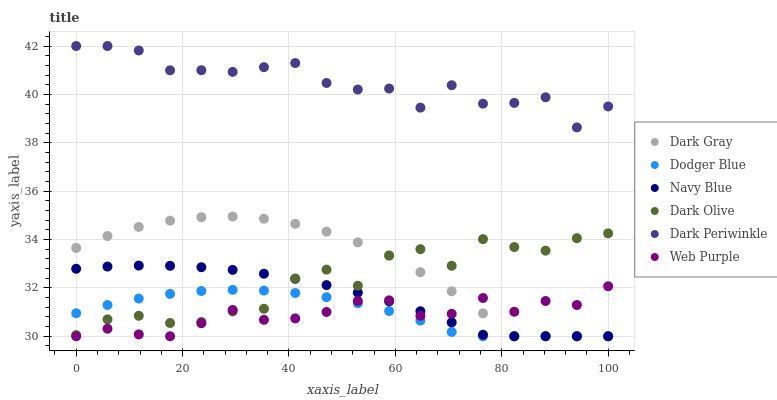Does Web Purple have the minimum area under the curve?
Answer yes or no. Yes. Does Dark Periwinkle have the maximum area under the curve?
Answer yes or no. Yes. Does Dark Olive have the minimum area under the curve?
Answer yes or no. No. Does Dark Olive have the maximum area under the curve?
Answer yes or no. No. Is Navy Blue the smoothest?
Answer yes or no. Yes. Is Dark Olive the roughest?
Answer yes or no. Yes. Is Dark Gray the smoothest?
Answer yes or no. No. Is Dark Gray the roughest?
Answer yes or no. No. Does Navy Blue have the lowest value?
Answer yes or no. Yes. Does Dark Olive have the lowest value?
Answer yes or no. No. Does Dark Periwinkle have the highest value?
Answer yes or no. Yes. Does Dark Olive have the highest value?
Answer yes or no. No. Is Web Purple less than Dark Periwinkle?
Answer yes or no. Yes. Is Dark Periwinkle greater than Navy Blue?
Answer yes or no. Yes. Does Navy Blue intersect Dodger Blue?
Answer yes or no. Yes. Is Navy Blue less than Dodger Blue?
Answer yes or no. No. Is Navy Blue greater than Dodger Blue?
Answer yes or no. No. Does Web Purple intersect Dark Periwinkle?
Answer yes or no. No. 